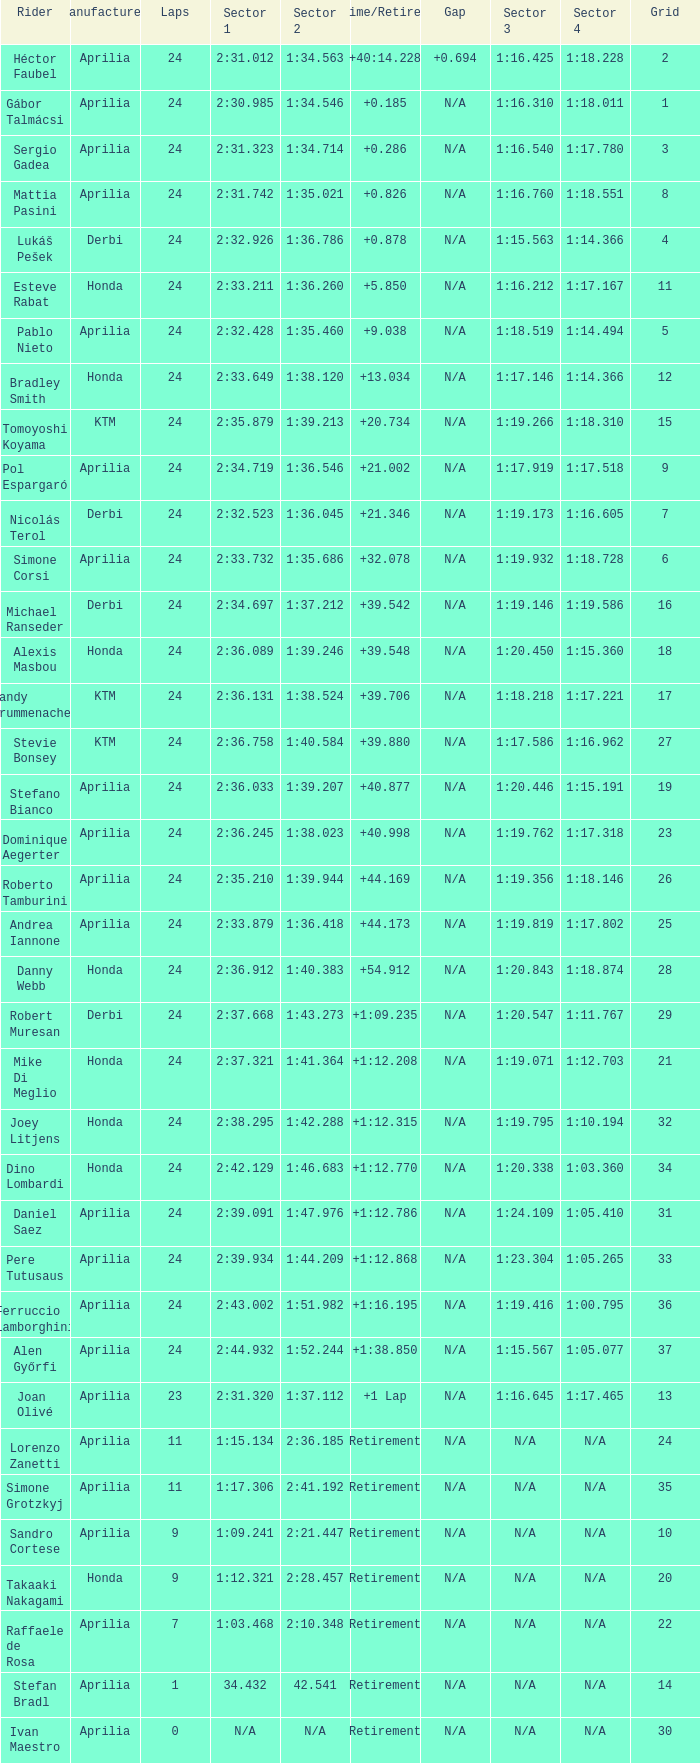How many grids correspond to more than 24 laps? None. Can you parse all the data within this table? {'header': ['Rider', 'Manufacturer', 'Laps', 'Sector 1', 'Sector 2', 'Time/Retired', 'Gap', 'Sector 3', 'Sector 4', 'Grid'], 'rows': [['Héctor Faubel', 'Aprilia', '24', '2:31.012', '1:34.563', '+40:14.228', '+0.694', '1:16.425', '1:18.228', '2'], ['Gábor Talmácsi', 'Aprilia', '24', '2:30.985', '1:34.546', '+0.185', 'N/A', '1:16.310', '1:18.011', '1'], ['Sergio Gadea', 'Aprilia', '24', '2:31.323', '1:34.714', '+0.286', 'N/A', '1:16.540', '1:17.780', '3'], ['Mattia Pasini', 'Aprilia', '24', '2:31.742', '1:35.021', '+0.826', 'N/A', '1:16.760', '1:18.551', '8'], ['Lukáš Pešek', 'Derbi', '24', '2:32.926', '1:36.786', '+0.878', 'N/A', '1:15.563', '1:14.366', '4'], ['Esteve Rabat', 'Honda', '24', '2:33.211', '1:36.260', '+5.850', 'N/A', '1:16.212', '1:17.167', '11'], ['Pablo Nieto', 'Aprilia', '24', '2:32.428', '1:35.460', '+9.038', 'N/A', '1:18.519', '1:14.494', '5'], ['Bradley Smith', 'Honda', '24', '2:33.649', '1:38.120', '+13.034', 'N/A', '1:17.146', '1:14.366', '12'], ['Tomoyoshi Koyama', 'KTM', '24', '2:35.879', '1:39.213', '+20.734', 'N/A', '1:19.266', '1:18.310', '15'], ['Pol Espargaró', 'Aprilia', '24', '2:34.719', '1:36.546', '+21.002', 'N/A', '1:17.919', '1:17.518', '9'], ['Nicolás Terol', 'Derbi', '24', '2:32.523', '1:36.045', '+21.346', 'N/A', '1:19.173', '1:16.605', '7'], ['Simone Corsi', 'Aprilia', '24', '2:33.732', '1:35.686', '+32.078', 'N/A', '1:19.932', '1:18.728', '6'], ['Michael Ranseder', 'Derbi', '24', '2:34.697', '1:37.212', '+39.542', 'N/A', '1:19.146', '1:19.586', '16'], ['Alexis Masbou', 'Honda', '24', '2:36.089', '1:39.246', '+39.548', 'N/A', '1:20.450', '1:15.360', '18'], ['Randy Krummenacher', 'KTM', '24', '2:36.131', '1:38.524', '+39.706', 'N/A', '1:18.218', '1:17.221', '17'], ['Stevie Bonsey', 'KTM', '24', '2:36.758', '1:40.584', '+39.880', 'N/A', '1:17.586', '1:16.962', '27'], ['Stefano Bianco', 'Aprilia', '24', '2:36.033', '1:39.207', '+40.877', 'N/A', '1:20.446', '1:15.191', '19'], ['Dominique Aegerter', 'Aprilia', '24', '2:36.245', '1:38.023', '+40.998', 'N/A', '1:19.762', '1:17.318', '23'], ['Roberto Tamburini', 'Aprilia', '24', '2:35.210', '1:39.944', '+44.169', 'N/A', '1:19.356', '1:18.146', '26'], ['Andrea Iannone', 'Aprilia', '24', '2:33.879', '1:36.418', '+44.173', 'N/A', '1:19.819', '1:17.802', '25'], ['Danny Webb', 'Honda', '24', '2:36.912', '1:40.383', '+54.912', 'N/A', '1:20.843', '1:18.874', '28'], ['Robert Muresan', 'Derbi', '24', '2:37.668', '1:43.273', '+1:09.235', 'N/A', '1:20.547', '1:11.767', '29'], ['Mike Di Meglio', 'Honda', '24', '2:37.321', '1:41.364', '+1:12.208', 'N/A', '1:19.071', '1:12.703', '21'], ['Joey Litjens', 'Honda', '24', '2:38.295', '1:42.288', '+1:12.315', 'N/A', '1:19.795', '1:10.194', '32'], ['Dino Lombardi', 'Honda', '24', '2:42.129', '1:46.683', '+1:12.770', 'N/A', '1:20.338', '1:03.360', '34'], ['Daniel Saez', 'Aprilia', '24', '2:39.091', '1:47.976', '+1:12.786', 'N/A', '1:24.109', '1:05.410', '31'], ['Pere Tutusaus', 'Aprilia', '24', '2:39.934', '1:44.209', '+1:12.868', 'N/A', '1:23.304', '1:05.265', '33'], ['Ferruccio Lamborghini', 'Aprilia', '24', '2:43.002', '1:51.982', '+1:16.195', 'N/A', '1:19.416', '1:00.795', '36'], ['Alen Győrfi', 'Aprilia', '24', '2:44.932', '1:52.244', '+1:38.850', 'N/A', '1:15.567', '1:05.077', '37'], ['Joan Olivé', 'Aprilia', '23', '2:31.320', '1:37.112', '+1 Lap', 'N/A', '1:16.645', '1:17.465', '13'], ['Lorenzo Zanetti', 'Aprilia', '11', '1:15.134', '2:36.185', 'Retirement', 'N/A', 'N/A', 'N/A', '24'], ['Simone Grotzkyj', 'Aprilia', '11', '1:17.306', '2:41.192', 'Retirement', 'N/A', 'N/A', 'N/A', '35'], ['Sandro Cortese', 'Aprilia', '9', '1:09.241', '2:21.447', 'Retirement', 'N/A', 'N/A', 'N/A', '10'], ['Takaaki Nakagami', 'Honda', '9', '1:12.321', '2:28.457', 'Retirement', 'N/A', 'N/A', 'N/A', '20'], ['Raffaele de Rosa', 'Aprilia', '7', '1:03.468', '2:10.348', 'Retirement', 'N/A', 'N/A', 'N/A', '22'], ['Stefan Bradl', 'Aprilia', '1', '34.432', '42.541', 'Retirement', 'N/A', 'N/A', 'N/A', '14'], ['Ivan Maestro', 'Aprilia', '0', 'N/A', 'N/A', 'Retirement', 'N/A', 'N/A', 'N/A', '30']]} 